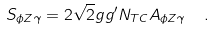<formula> <loc_0><loc_0><loc_500><loc_500>S _ { \phi Z \gamma } = 2 \sqrt { 2 } g g ^ { \prime } N _ { T C } A _ { \phi Z \gamma } \ \ .</formula> 